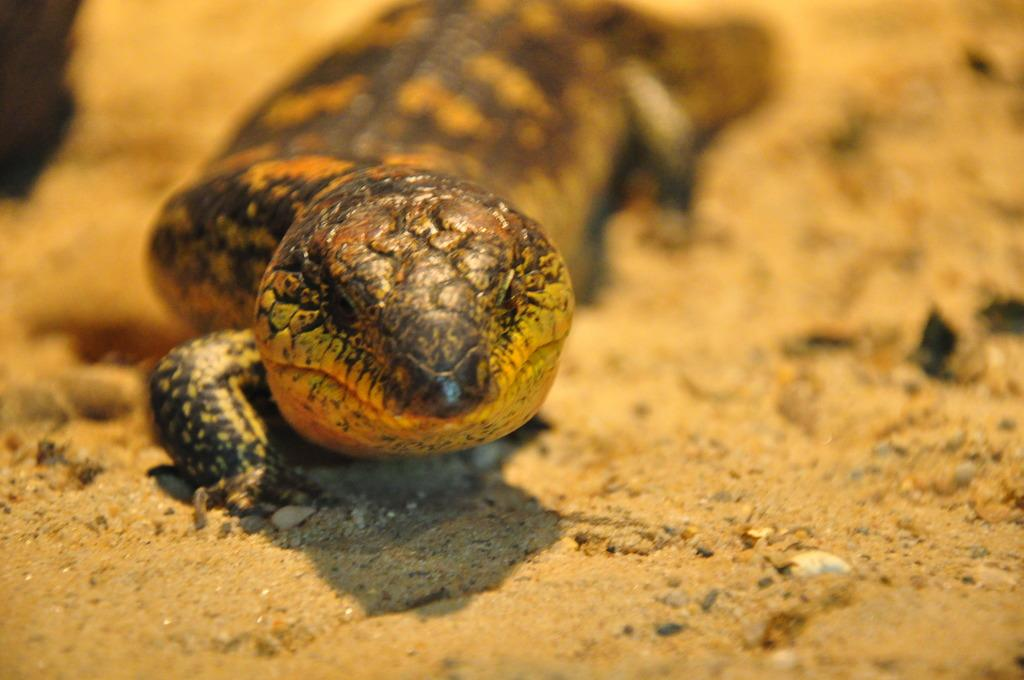What type of animal is in the image? There is a salamander in the image. Where is the salamander located? The salamander is on the ground. What type of sweater is the salamander wearing in the image? There is no sweater present in the image, as salamanders do not wear clothing. 